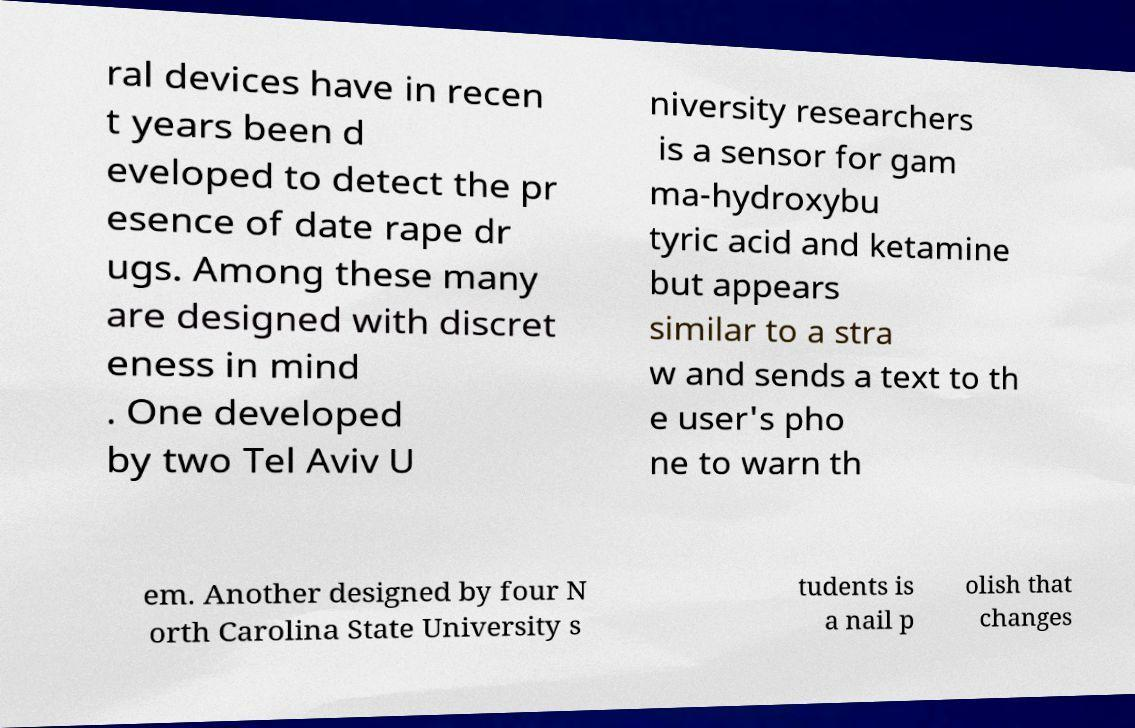For documentation purposes, I need the text within this image transcribed. Could you provide that? ral devices have in recen t years been d eveloped to detect the pr esence of date rape dr ugs. Among these many are designed with discret eness in mind . One developed by two Tel Aviv U niversity researchers is a sensor for gam ma-hydroxybu tyric acid and ketamine but appears similar to a stra w and sends a text to th e user's pho ne to warn th em. Another designed by four N orth Carolina State University s tudents is a nail p olish that changes 